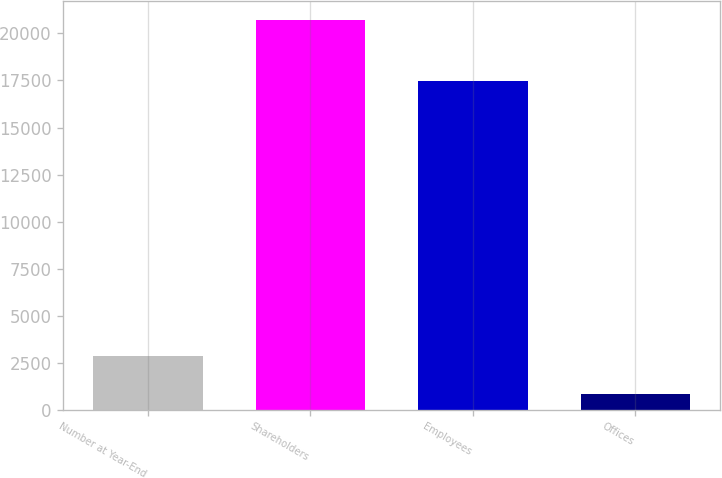Convert chart. <chart><loc_0><loc_0><loc_500><loc_500><bar_chart><fcel>Number at Year-End<fcel>Shareholders<fcel>Employees<fcel>Offices<nl><fcel>2846<fcel>20693<fcel>17476<fcel>863<nl></chart> 